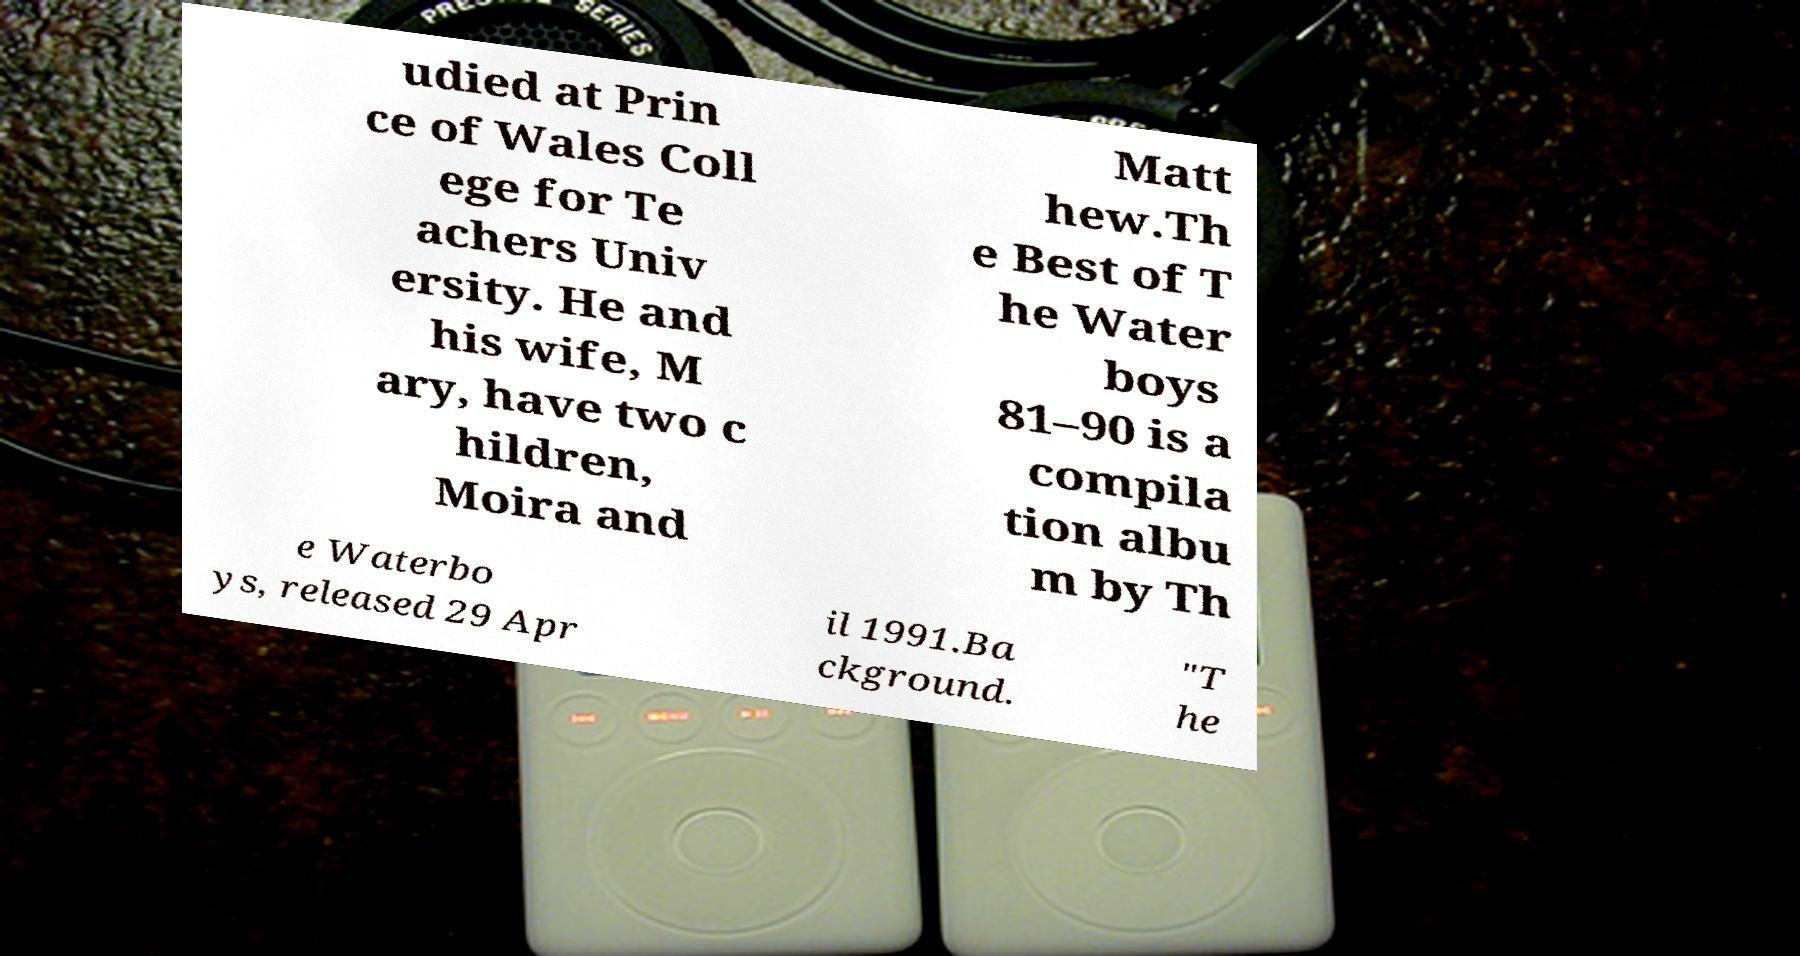Please identify and transcribe the text found in this image. udied at Prin ce of Wales Coll ege for Te achers Univ ersity. He and his wife, M ary, have two c hildren, Moira and Matt hew.Th e Best of T he Water boys 81–90 is a compila tion albu m by Th e Waterbo ys, released 29 Apr il 1991.Ba ckground. "T he 